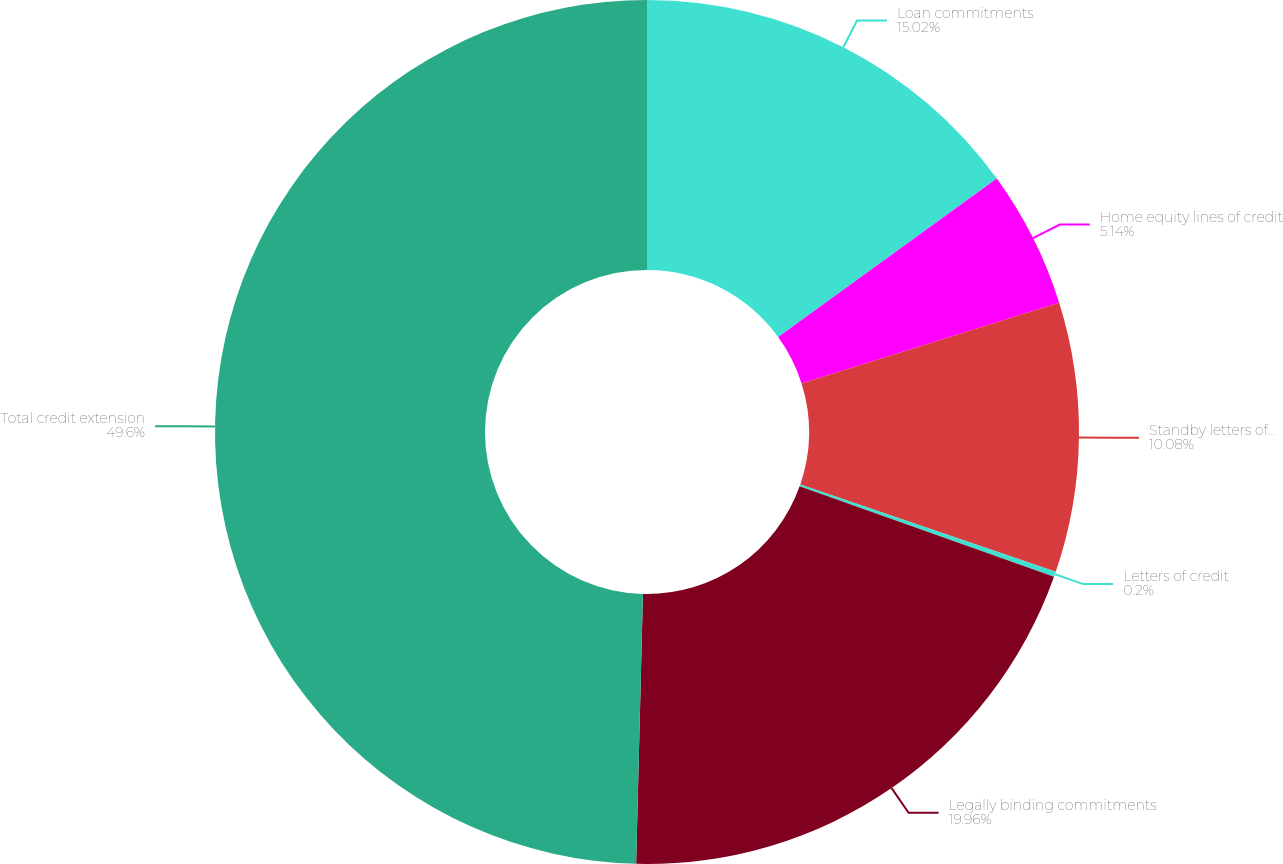Convert chart. <chart><loc_0><loc_0><loc_500><loc_500><pie_chart><fcel>Loan commitments<fcel>Home equity lines of credit<fcel>Standby letters of credit and<fcel>Letters of credit<fcel>Legally binding commitments<fcel>Total credit extension<nl><fcel>15.02%<fcel>5.14%<fcel>10.08%<fcel>0.2%<fcel>19.96%<fcel>49.6%<nl></chart> 